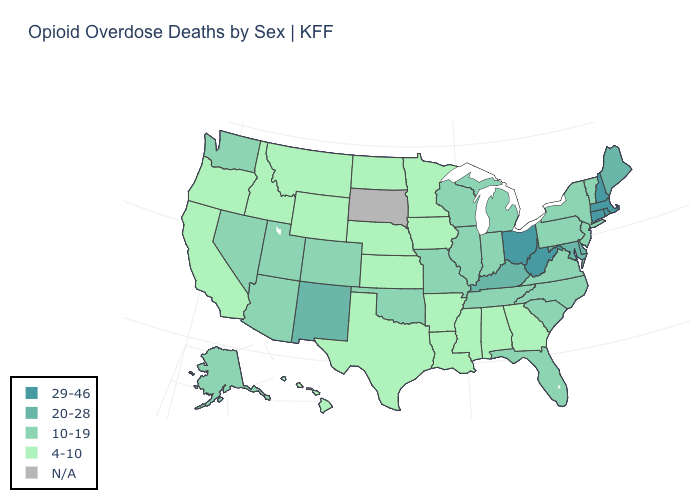How many symbols are there in the legend?
Keep it brief. 5. What is the value of New Hampshire?
Answer briefly. 29-46. Among the states that border New Hampshire , which have the lowest value?
Concise answer only. Vermont. What is the highest value in the West ?
Concise answer only. 20-28. Name the states that have a value in the range 4-10?
Concise answer only. Alabama, Arkansas, California, Georgia, Hawaii, Idaho, Iowa, Kansas, Louisiana, Minnesota, Mississippi, Montana, Nebraska, North Dakota, Oregon, Texas, Wyoming. What is the value of Utah?
Be succinct. 10-19. What is the highest value in the West ?
Short answer required. 20-28. What is the lowest value in the Northeast?
Answer briefly. 10-19. Among the states that border Illinois , which have the lowest value?
Be succinct. Iowa. What is the value of Georgia?
Concise answer only. 4-10. Among the states that border Arkansas , does Texas have the highest value?
Give a very brief answer. No. Which states hav the highest value in the West?
Write a very short answer. New Mexico. Does the map have missing data?
Short answer required. Yes. 